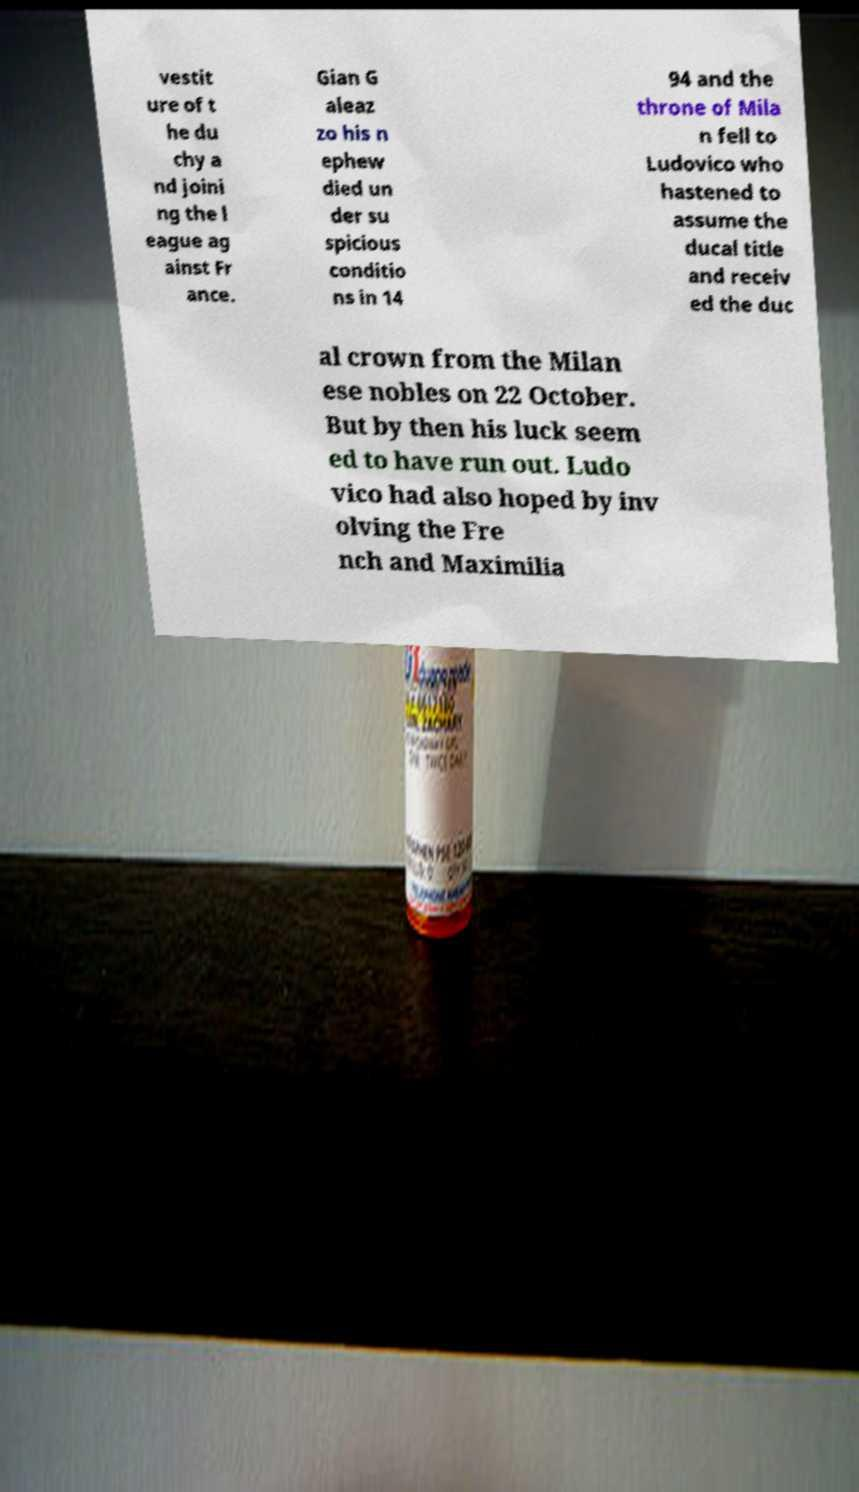For documentation purposes, I need the text within this image transcribed. Could you provide that? vestit ure of t he du chy a nd joini ng the l eague ag ainst Fr ance. Gian G aleaz zo his n ephew died un der su spicious conditio ns in 14 94 and the throne of Mila n fell to Ludovico who hastened to assume the ducal title and receiv ed the duc al crown from the Milan ese nobles on 22 October. But by then his luck seem ed to have run out. Ludo vico had also hoped by inv olving the Fre nch and Maximilia 